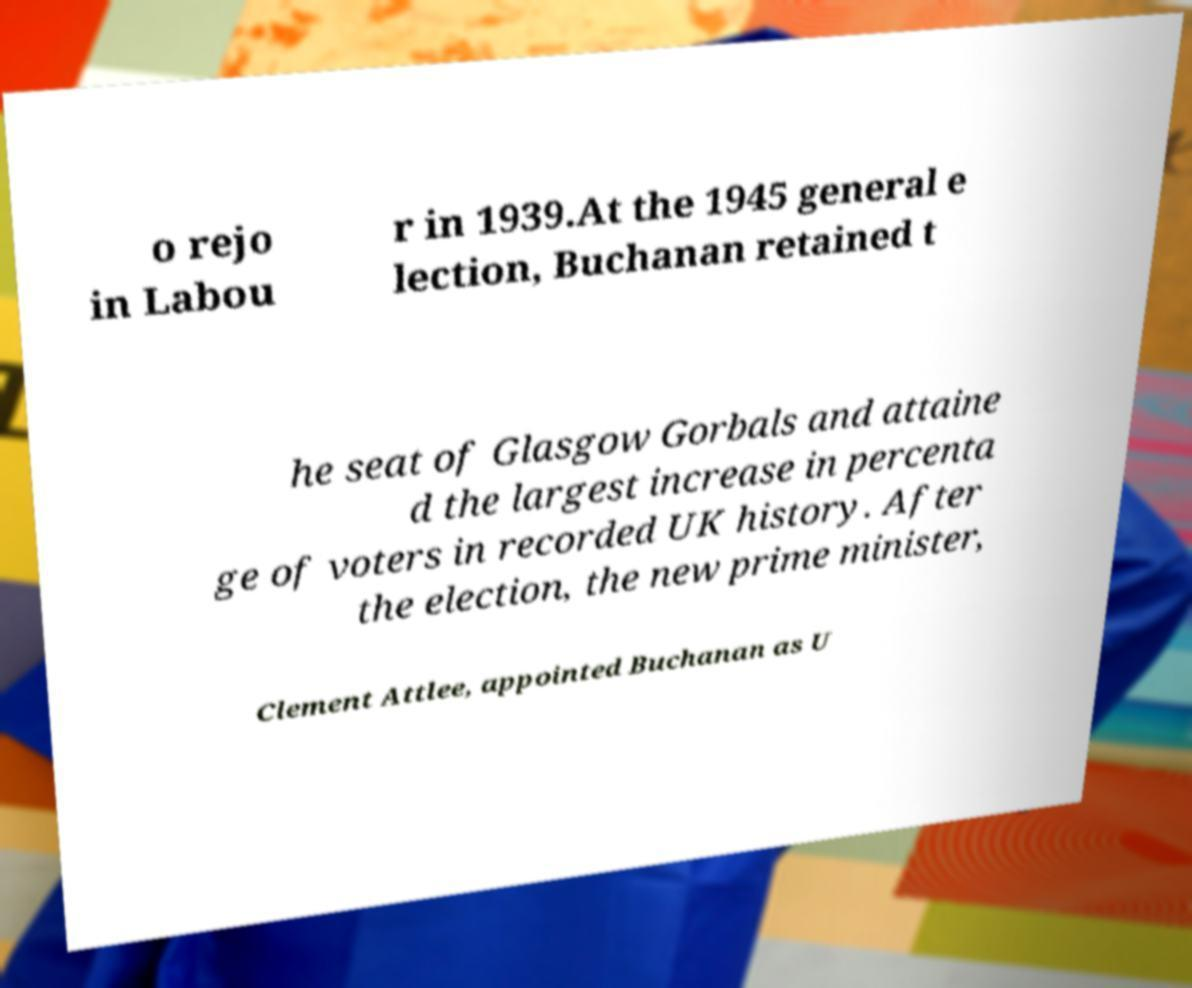Please identify and transcribe the text found in this image. o rejo in Labou r in 1939.At the 1945 general e lection, Buchanan retained t he seat of Glasgow Gorbals and attaine d the largest increase in percenta ge of voters in recorded UK history. After the election, the new prime minister, Clement Attlee, appointed Buchanan as U 